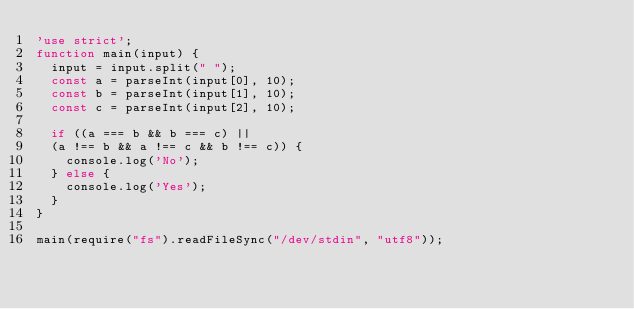Convert code to text. <code><loc_0><loc_0><loc_500><loc_500><_JavaScript_>'use strict';
function main(input) {
  input = input.split(" ");
  const a = parseInt(input[0], 10);
  const b = parseInt(input[1], 10);
  const c = parseInt(input[2], 10);
  
  if ((a === b && b === c) || 
  (a !== b && a !== c && b !== c)) {
    console.log('No');
  } else {
    console.log('Yes');
  }
}

main(require("fs").readFileSync("/dev/stdin", "utf8"));</code> 